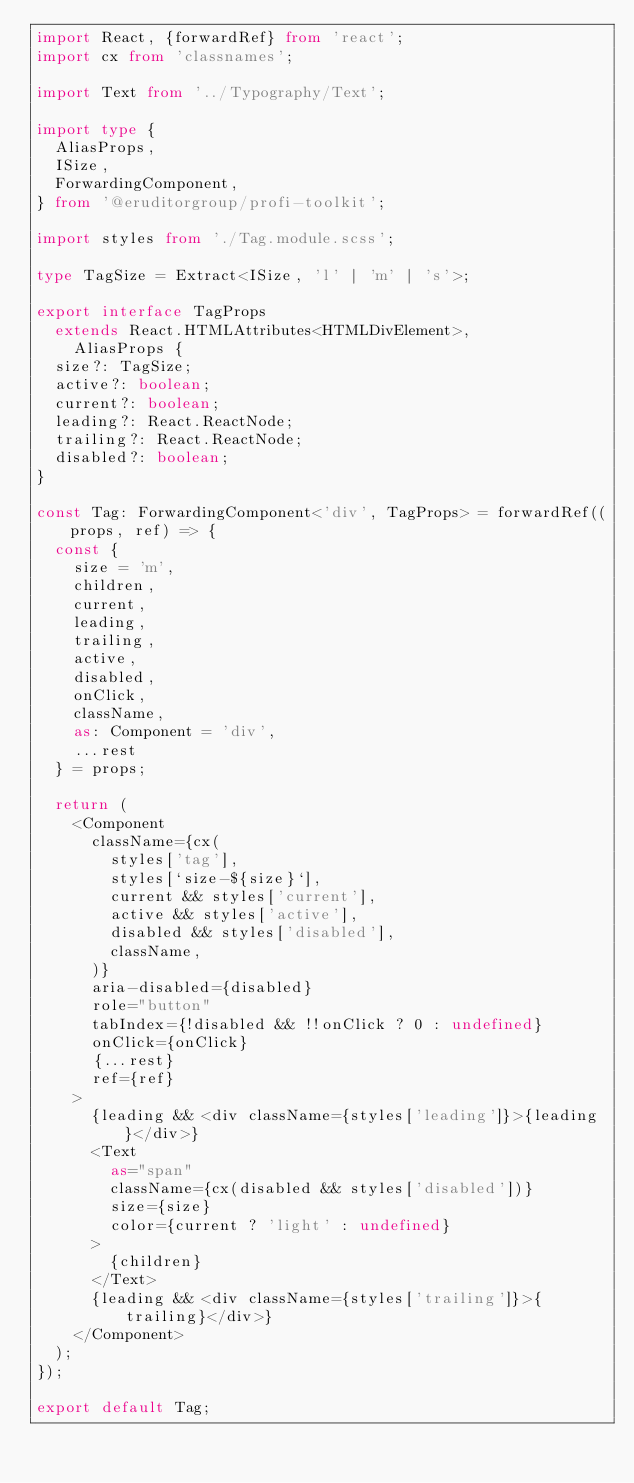<code> <loc_0><loc_0><loc_500><loc_500><_TypeScript_>import React, {forwardRef} from 'react';
import cx from 'classnames';

import Text from '../Typography/Text';

import type {
  AliasProps,
  ISize,
  ForwardingComponent,
} from '@eruditorgroup/profi-toolkit';

import styles from './Tag.module.scss';

type TagSize = Extract<ISize, 'l' | 'm' | 's'>;

export interface TagProps
  extends React.HTMLAttributes<HTMLDivElement>,
    AliasProps {
  size?: TagSize;
  active?: boolean;
  current?: boolean;
  leading?: React.ReactNode;
  trailing?: React.ReactNode;
  disabled?: boolean;
}

const Tag: ForwardingComponent<'div', TagProps> = forwardRef((props, ref) => {
  const {
    size = 'm',
    children,
    current,
    leading,
    trailing,
    active,
    disabled,
    onClick,
    className,
    as: Component = 'div',
    ...rest
  } = props;

  return (
    <Component
      className={cx(
        styles['tag'],
        styles[`size-${size}`],
        current && styles['current'],
        active && styles['active'],
        disabled && styles['disabled'],
        className,
      )}
      aria-disabled={disabled}
      role="button"
      tabIndex={!disabled && !!onClick ? 0 : undefined}
      onClick={onClick}
      {...rest}
      ref={ref}
    >
      {leading && <div className={styles['leading']}>{leading}</div>}
      <Text
        as="span"
        className={cx(disabled && styles['disabled'])}
        size={size}
        color={current ? 'light' : undefined}
      >
        {children}
      </Text>
      {leading && <div className={styles['trailing']}>{trailing}</div>}
    </Component>
  );
});

export default Tag;
</code> 